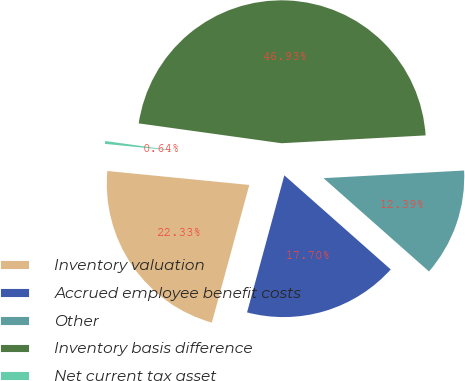Convert chart to OTSL. <chart><loc_0><loc_0><loc_500><loc_500><pie_chart><fcel>Inventory valuation<fcel>Accrued employee benefit costs<fcel>Other<fcel>Inventory basis difference<fcel>Net current tax asset<nl><fcel>22.33%<fcel>17.7%<fcel>12.39%<fcel>46.93%<fcel>0.64%<nl></chart> 